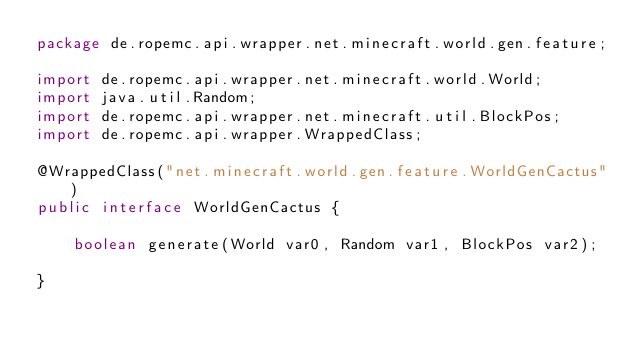Convert code to text. <code><loc_0><loc_0><loc_500><loc_500><_Java_>package de.ropemc.api.wrapper.net.minecraft.world.gen.feature;

import de.ropemc.api.wrapper.net.minecraft.world.World;
import java.util.Random;
import de.ropemc.api.wrapper.net.minecraft.util.BlockPos;
import de.ropemc.api.wrapper.WrappedClass;

@WrappedClass("net.minecraft.world.gen.feature.WorldGenCactus")
public interface WorldGenCactus {

    boolean generate(World var0, Random var1, BlockPos var2);

}
</code> 